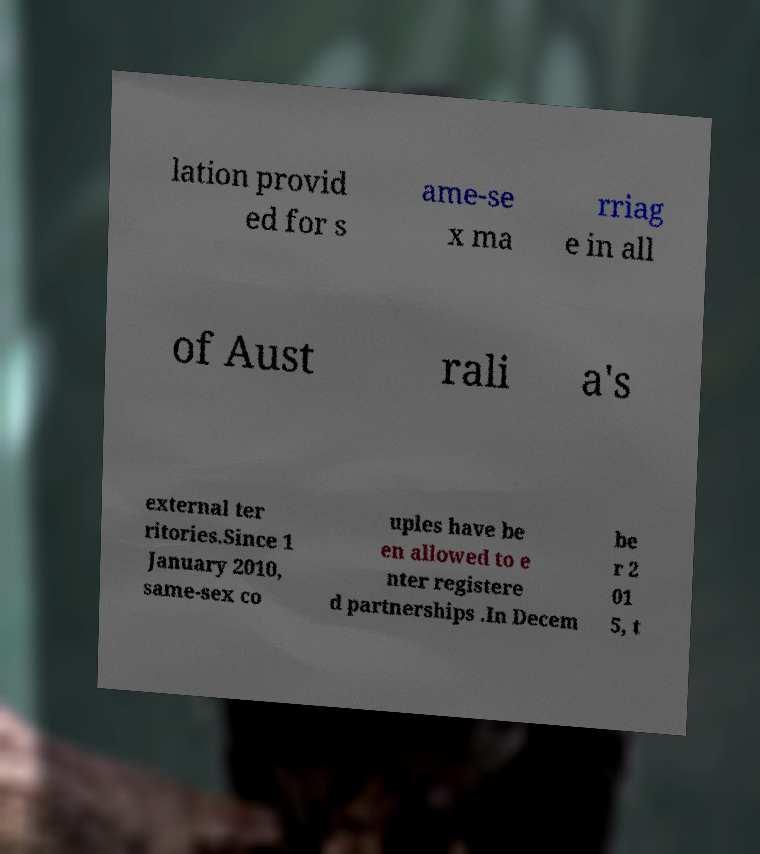Can you accurately transcribe the text from the provided image for me? lation provid ed for s ame-se x ma rriag e in all of Aust rali a's external ter ritories.Since 1 January 2010, same-sex co uples have be en allowed to e nter registere d partnerships .In Decem be r 2 01 5, t 